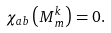Convert formula to latex. <formula><loc_0><loc_0><loc_500><loc_500>\chi _ { a b } \left ( M _ { \, m } ^ { k } \right ) = 0 .</formula> 